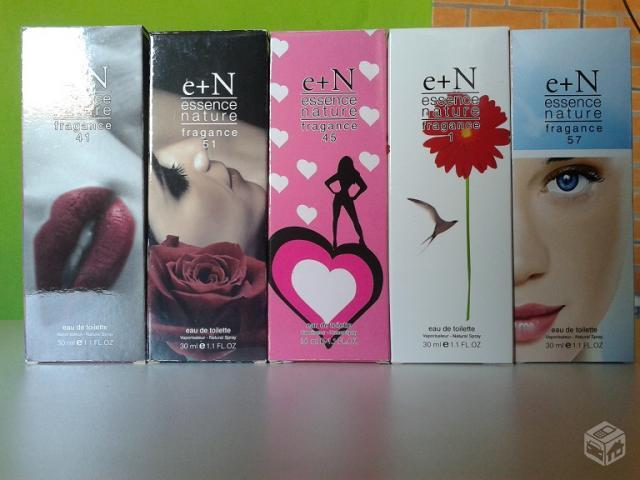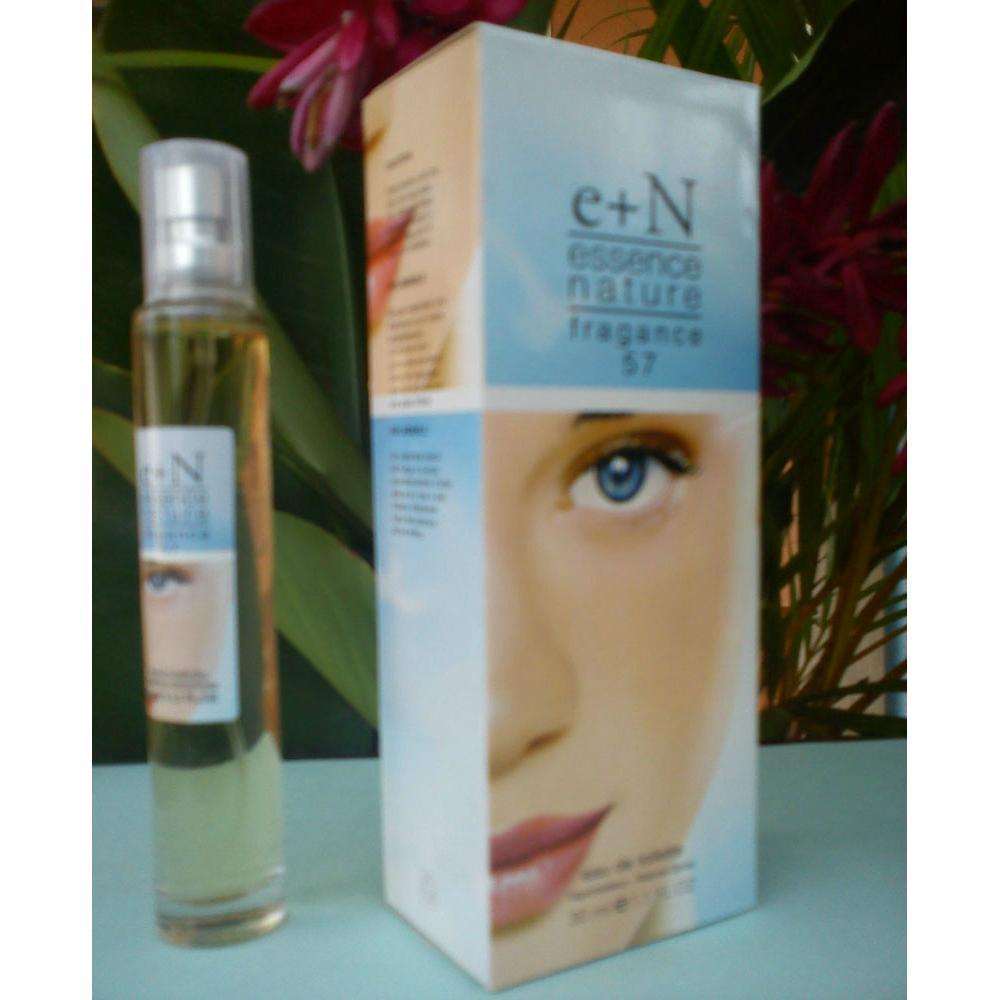The first image is the image on the left, the second image is the image on the right. Assess this claim about the two images: "In one image, a single slender spray bottle stands to the left of a box with a woman's face on it.". Correct or not? Answer yes or no. Yes. The first image is the image on the left, the second image is the image on the right. Given the left and right images, does the statement "The right image contains one slim cylinder perfume bottle that is to the left of its packaging case." hold true? Answer yes or no. Yes. 